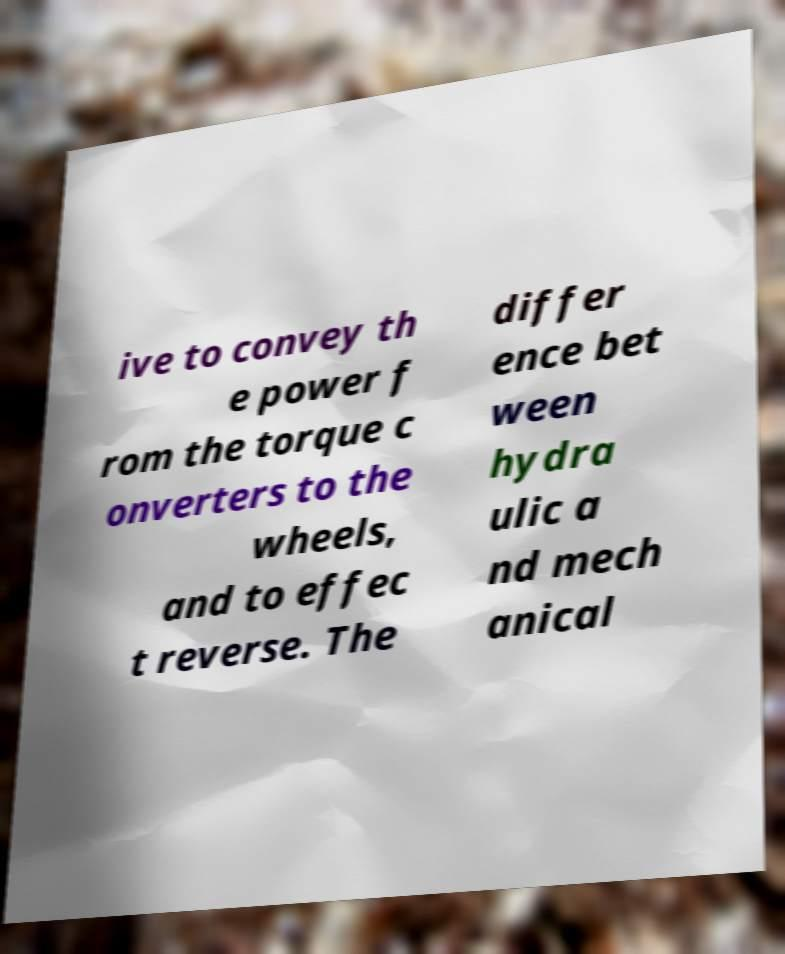Please read and relay the text visible in this image. What does it say? ive to convey th e power f rom the torque c onverters to the wheels, and to effec t reverse. The differ ence bet ween hydra ulic a nd mech anical 